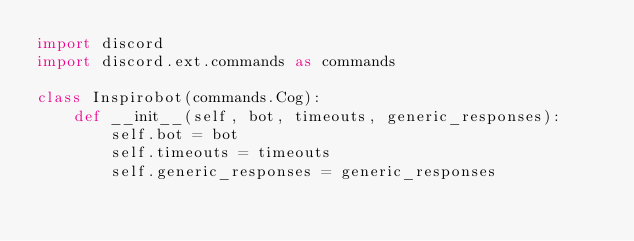<code> <loc_0><loc_0><loc_500><loc_500><_Python_>import discord
import discord.ext.commands as commands

class Inspirobot(commands.Cog):
    def __init__(self, bot, timeouts, generic_responses):
        self.bot = bot
        self.timeouts = timeouts
        self.generic_responses = generic_responses</code> 